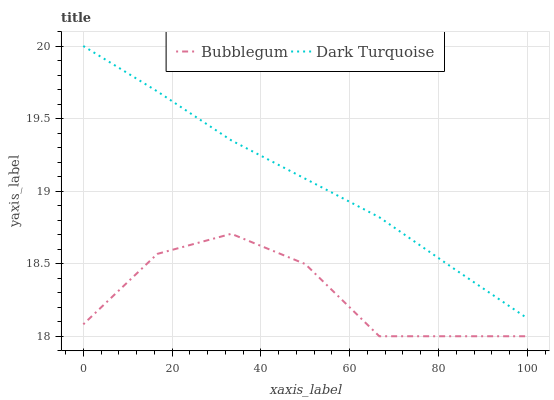Does Bubblegum have the minimum area under the curve?
Answer yes or no. Yes. Does Dark Turquoise have the maximum area under the curve?
Answer yes or no. Yes. Does Bubblegum have the maximum area under the curve?
Answer yes or no. No. Is Dark Turquoise the smoothest?
Answer yes or no. Yes. Is Bubblegum the roughest?
Answer yes or no. Yes. Is Bubblegum the smoothest?
Answer yes or no. No. Does Bubblegum have the lowest value?
Answer yes or no. Yes. Does Dark Turquoise have the highest value?
Answer yes or no. Yes. Does Bubblegum have the highest value?
Answer yes or no. No. Is Bubblegum less than Dark Turquoise?
Answer yes or no. Yes. Is Dark Turquoise greater than Bubblegum?
Answer yes or no. Yes. Does Bubblegum intersect Dark Turquoise?
Answer yes or no. No. 